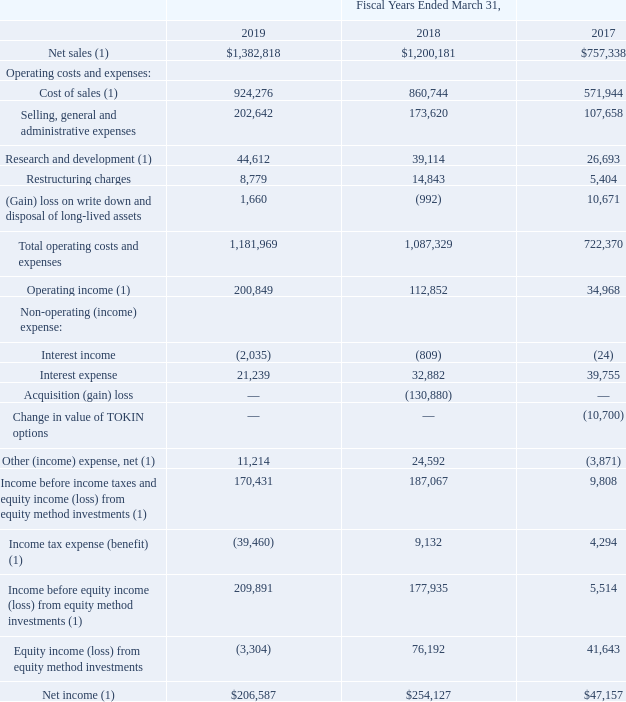Results of Operations
Historically, revenues and earnings may or may not be representative of future operating results due to various economic and other factors. The following table sets forth the Consolidated Statements of Operations for the periods indicated (amounts in thousands):
(1) Fiscal years ended March 31, 2018 and 2017 adjusted due to the adoption of ASC 606.
Why were calculations for Fiscal years ended March 31, 2018 and 2017 adjusted? Due to the adoption of asc 606. Which years does the table provide information for the company's Consolidated Statements of Operations? 2019, 2018, 2017. What were the net sales in 2019?
Answer scale should be: thousand. 1,382,818. How many years did net other (income) expense exceed $10,000 thousand? 2019##2018
Answer: 2. What was the change in Interest expense between 2017 and 2018?
Answer scale should be: thousand. 32,882-39,755
Answer: -6873. What was the percentage change in the net income between 2018 and 2019?
Answer scale should be: percent. (206,587-254,127)/254,127
Answer: -18.71. 